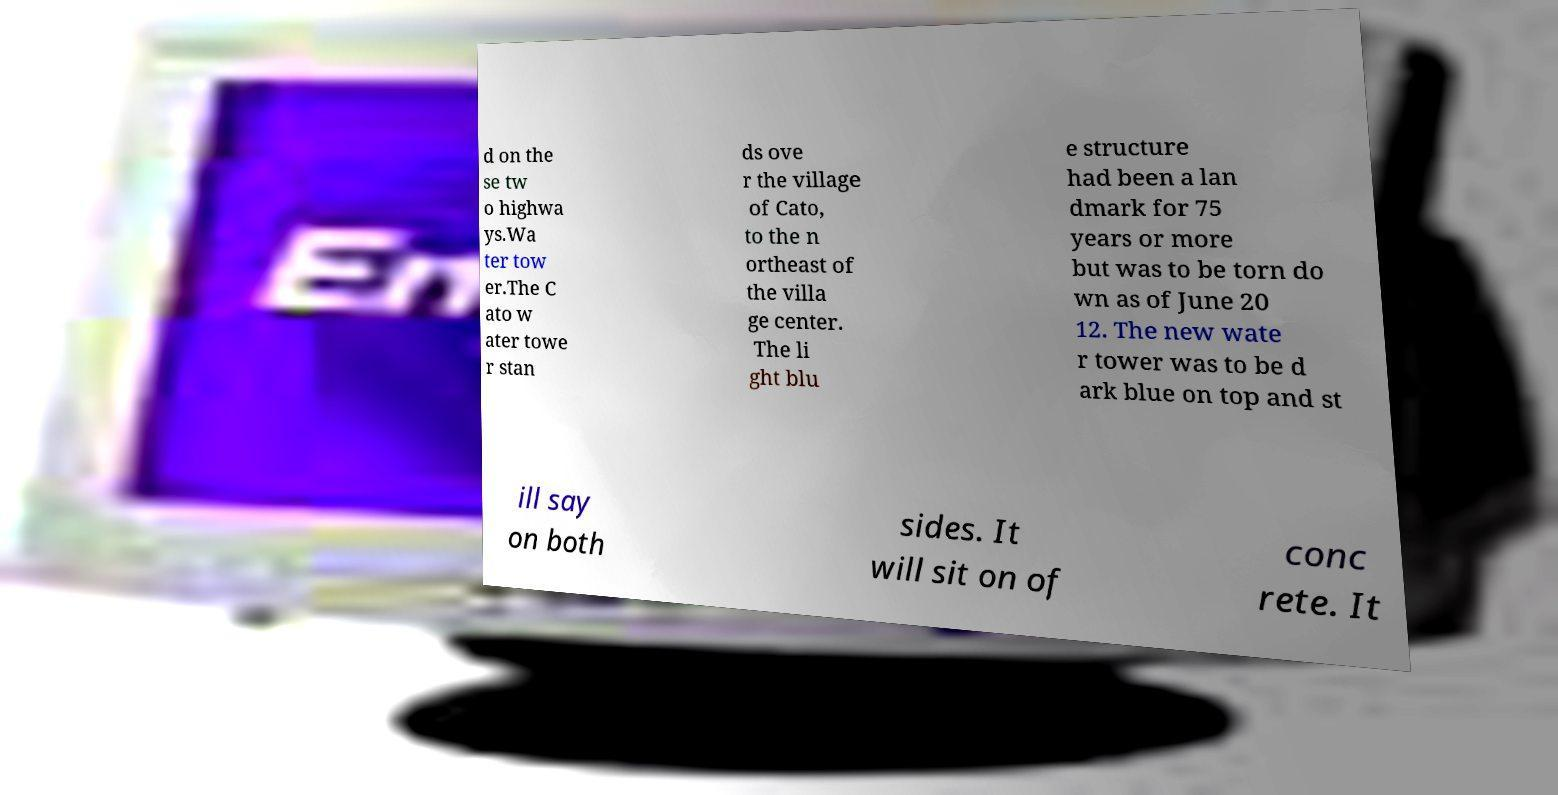Can you accurately transcribe the text from the provided image for me? d on the se tw o highwa ys.Wa ter tow er.The C ato w ater towe r stan ds ove r the village of Cato, to the n ortheast of the villa ge center. The li ght blu e structure had been a lan dmark for 75 years or more but was to be torn do wn as of June 20 12. The new wate r tower was to be d ark blue on top and st ill say on both sides. It will sit on of conc rete. It 